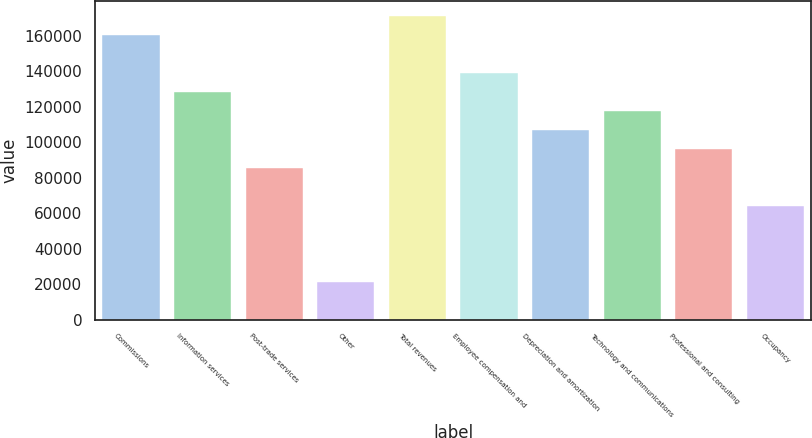Convert chart to OTSL. <chart><loc_0><loc_0><loc_500><loc_500><bar_chart><fcel>Commissions<fcel>Information services<fcel>Post-trade services<fcel>Other<fcel>Total revenues<fcel>Employee compensation and<fcel>Depreciation and amortization<fcel>Technology and communications<fcel>Professional and consulting<fcel>Occupancy<nl><fcel>160445<fcel>128357<fcel>85571.4<fcel>21393.7<fcel>171142<fcel>139053<fcel>106964<fcel>117660<fcel>96267.7<fcel>64178.8<nl></chart> 